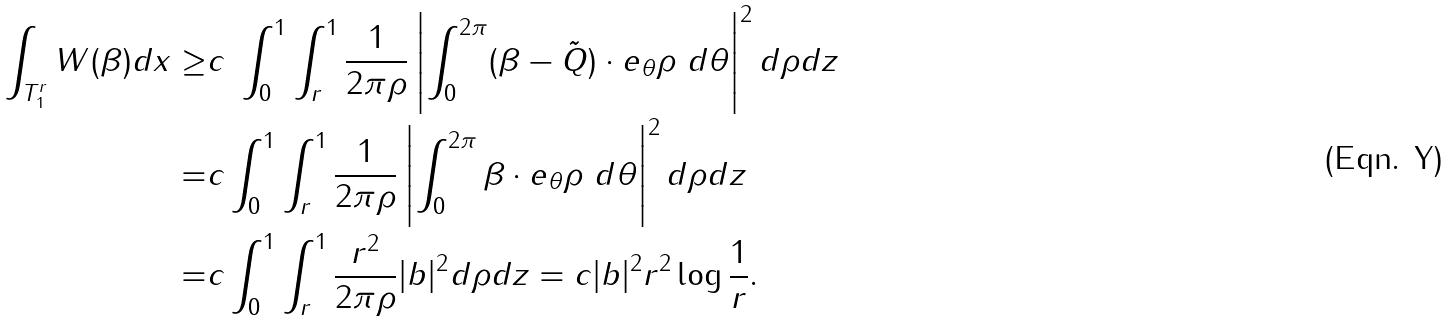<formula> <loc_0><loc_0><loc_500><loc_500>\int _ { T _ { 1 } ^ { r } } W ( \beta ) d x \geq & c \ \int _ { 0 } ^ { 1 } \int _ { r } ^ { 1 } \frac { 1 } { 2 \pi \rho } \left | \int _ { 0 } ^ { 2 \pi } ( \beta - \tilde { Q } ) \cdot e _ { \theta } \rho \ d \theta \right | ^ { 2 } d \rho d z \\ = & c \int _ { 0 } ^ { 1 } \int _ { r } ^ { 1 } \frac { 1 } { 2 \pi \rho } \left | \int _ { 0 } ^ { 2 \pi } \beta \cdot e _ { \theta } \rho \ d \theta \right | ^ { 2 } d \rho d z \\ = & c \int _ { 0 } ^ { 1 } \int _ { r } ^ { 1 } \frac { r ^ { 2 } } { 2 \pi \rho } | b | ^ { 2 } d \rho d z = c | b | ^ { 2 } r ^ { 2 } \log \frac { 1 } { r } .</formula> 